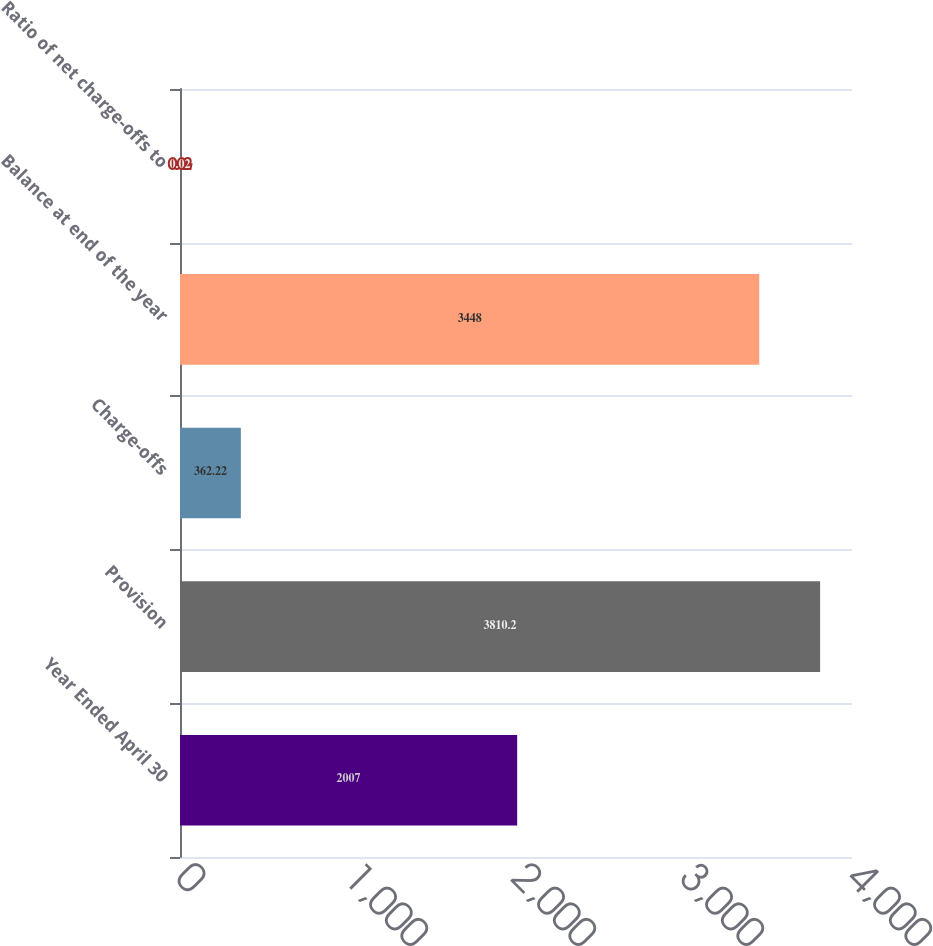<chart> <loc_0><loc_0><loc_500><loc_500><bar_chart><fcel>Year Ended April 30<fcel>Provision<fcel>Charge-offs<fcel>Balance at end of the year<fcel>Ratio of net charge-offs to<nl><fcel>2007<fcel>3810.2<fcel>362.22<fcel>3448<fcel>0.02<nl></chart> 